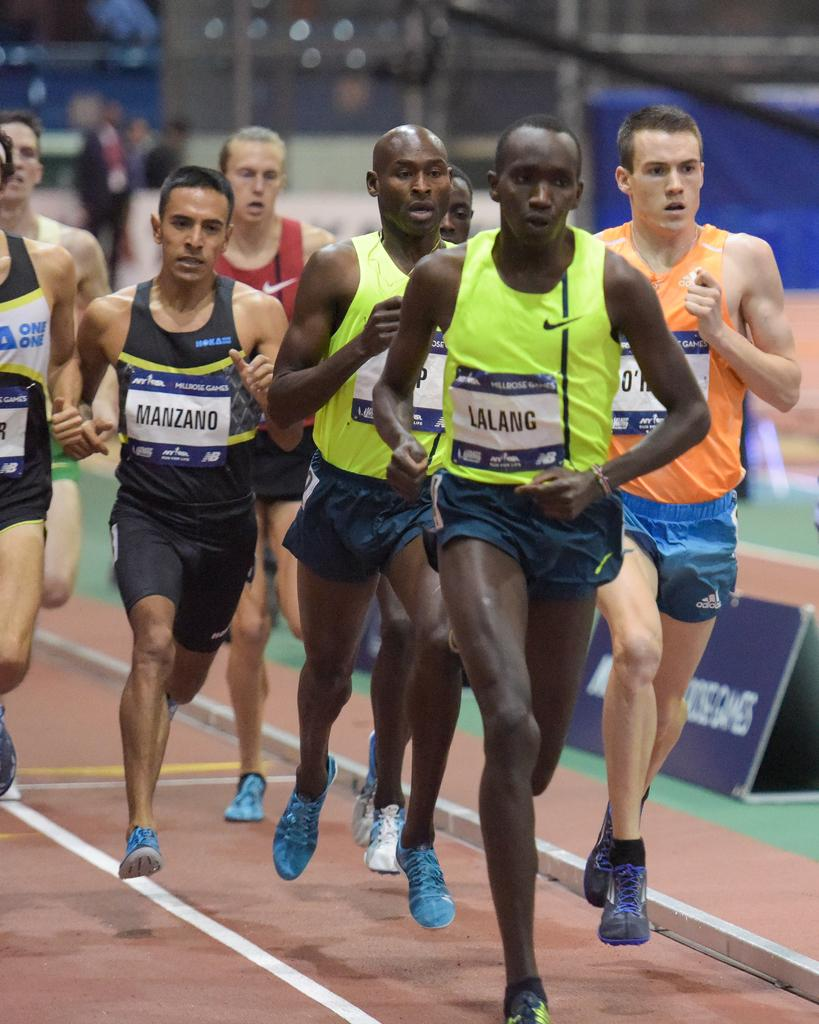<image>
Relay a brief, clear account of the picture shown. The runner named Lalang is leading the pack of runners on the track. 